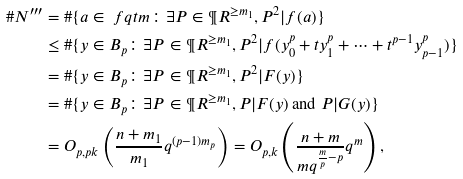Convert formula to latex. <formula><loc_0><loc_0><loc_500><loc_500>\# N ^ { \prime \prime \prime } & = \# \{ a \in \ f q t m \colon \exists P \in \P R ^ { \geq m _ { 1 } } , P ^ { 2 } | f ( a ) \} \\ & \leq \# \{ y \in B _ { p } \colon \exists P \in \P R ^ { \geq m _ { 1 } } , P ^ { 2 } | f ( y _ { 0 } ^ { p } + t y _ { 1 } ^ { p } + \cdots + t ^ { p - 1 } y _ { p - 1 } ^ { p } ) \} \\ & = \# \{ y \in B _ { p } \colon \exists P \in \P R ^ { \geq m _ { 1 } } , P ^ { 2 } | F ( y ) \} \\ & = \# \{ y \in B _ { p } \colon \exists P \in \P R ^ { \geq m _ { 1 } } , P | F ( y ) \text { and } P | G ( y ) \} \\ & = O _ { p , p k } \left ( \frac { n + m _ { 1 } } { m _ { 1 } } q ^ { ( p - 1 ) m _ { p } } \right ) = O _ { p , k } \left ( \frac { n + m } { m q ^ { \frac { m } { p } - p } } q ^ { m } \right ) ,</formula> 